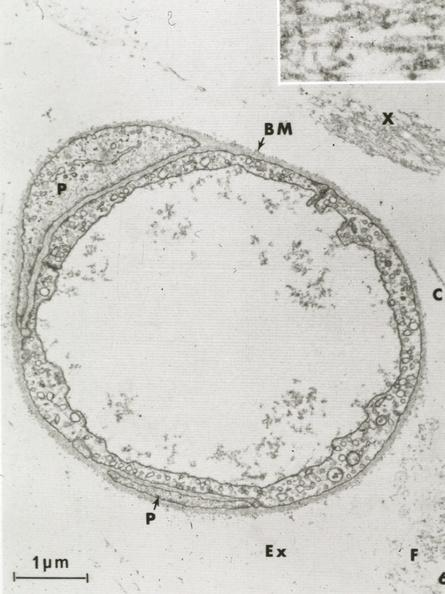where is this mage from?
Answer the question using a single word or phrase. Capillary 